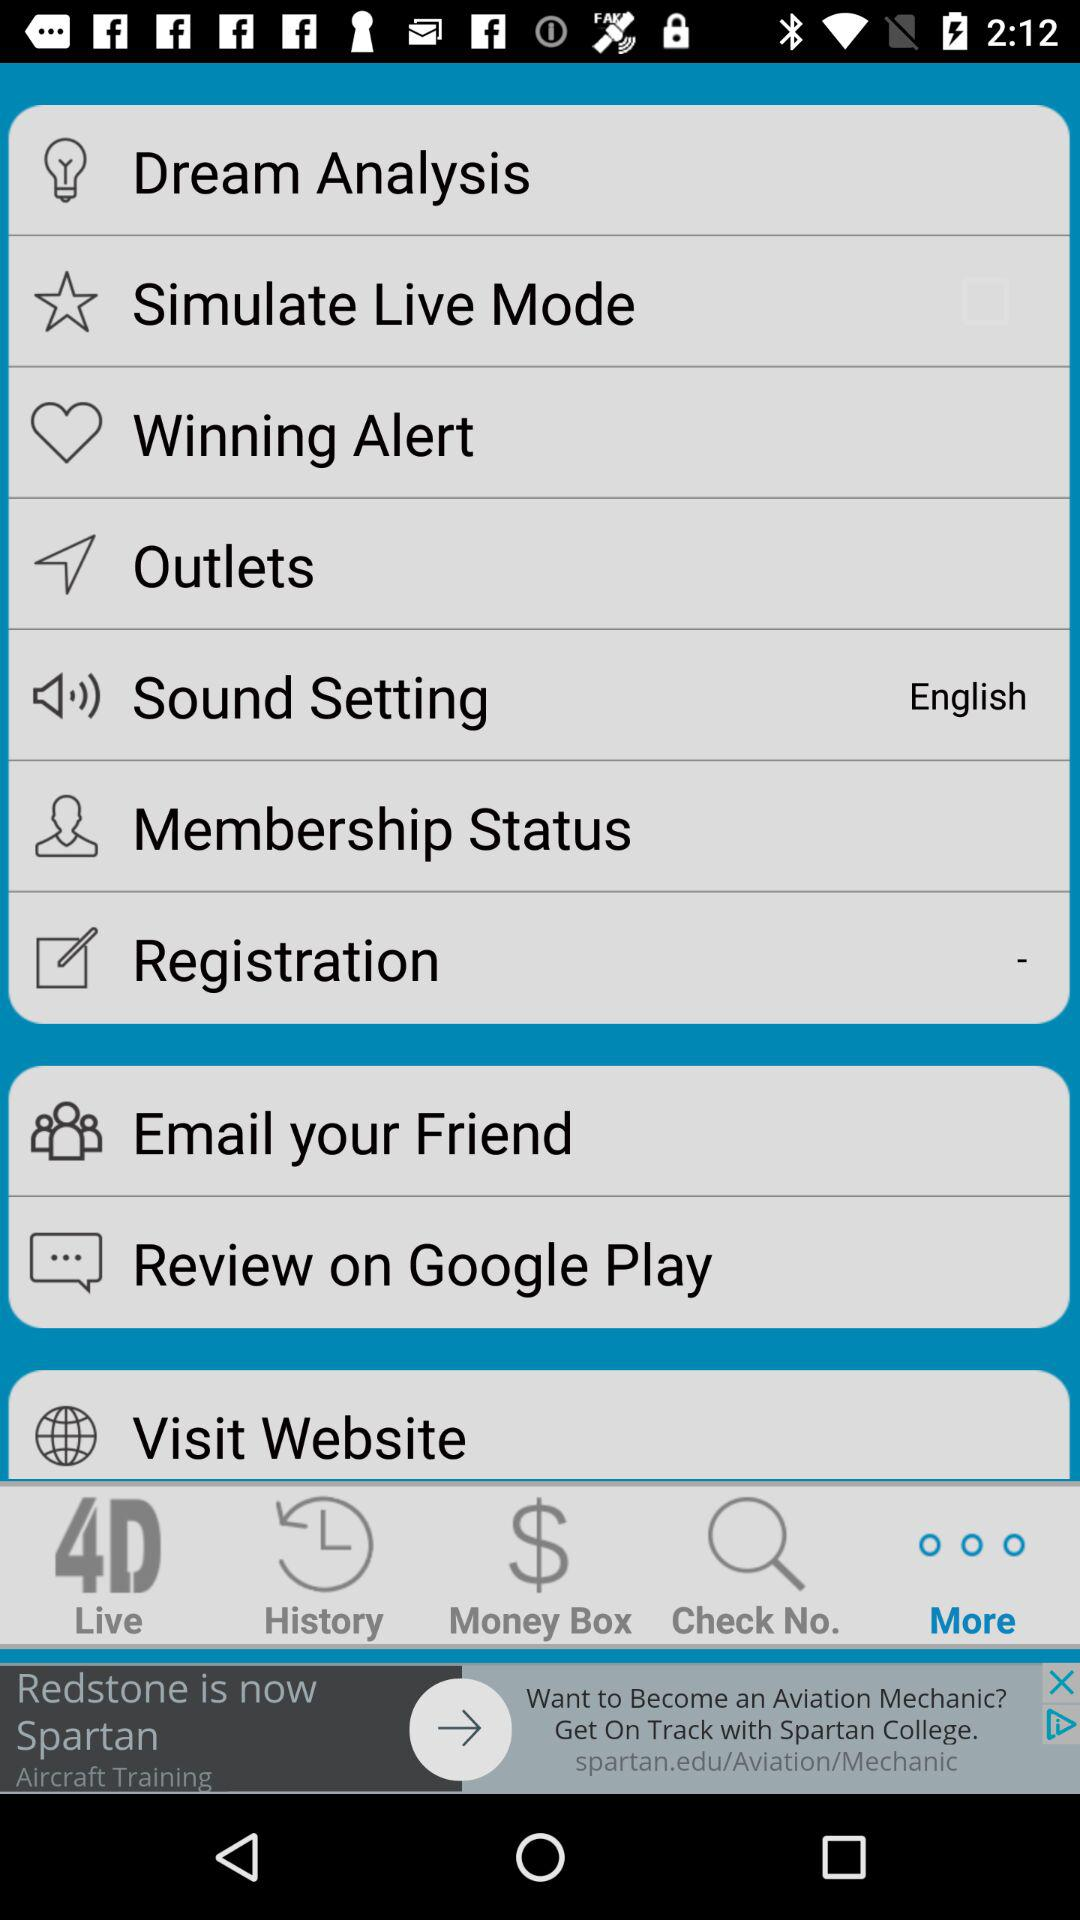What is the selected language in "Sound Setting"? The selected language is English. 